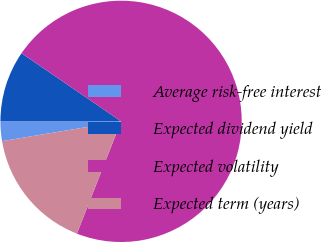Convert chart to OTSL. <chart><loc_0><loc_0><loc_500><loc_500><pie_chart><fcel>Average risk-free interest<fcel>Expected dividend yield<fcel>Expected volatility<fcel>Expected term (years)<nl><fcel>2.65%<fcel>9.53%<fcel>71.42%<fcel>16.41%<nl></chart> 